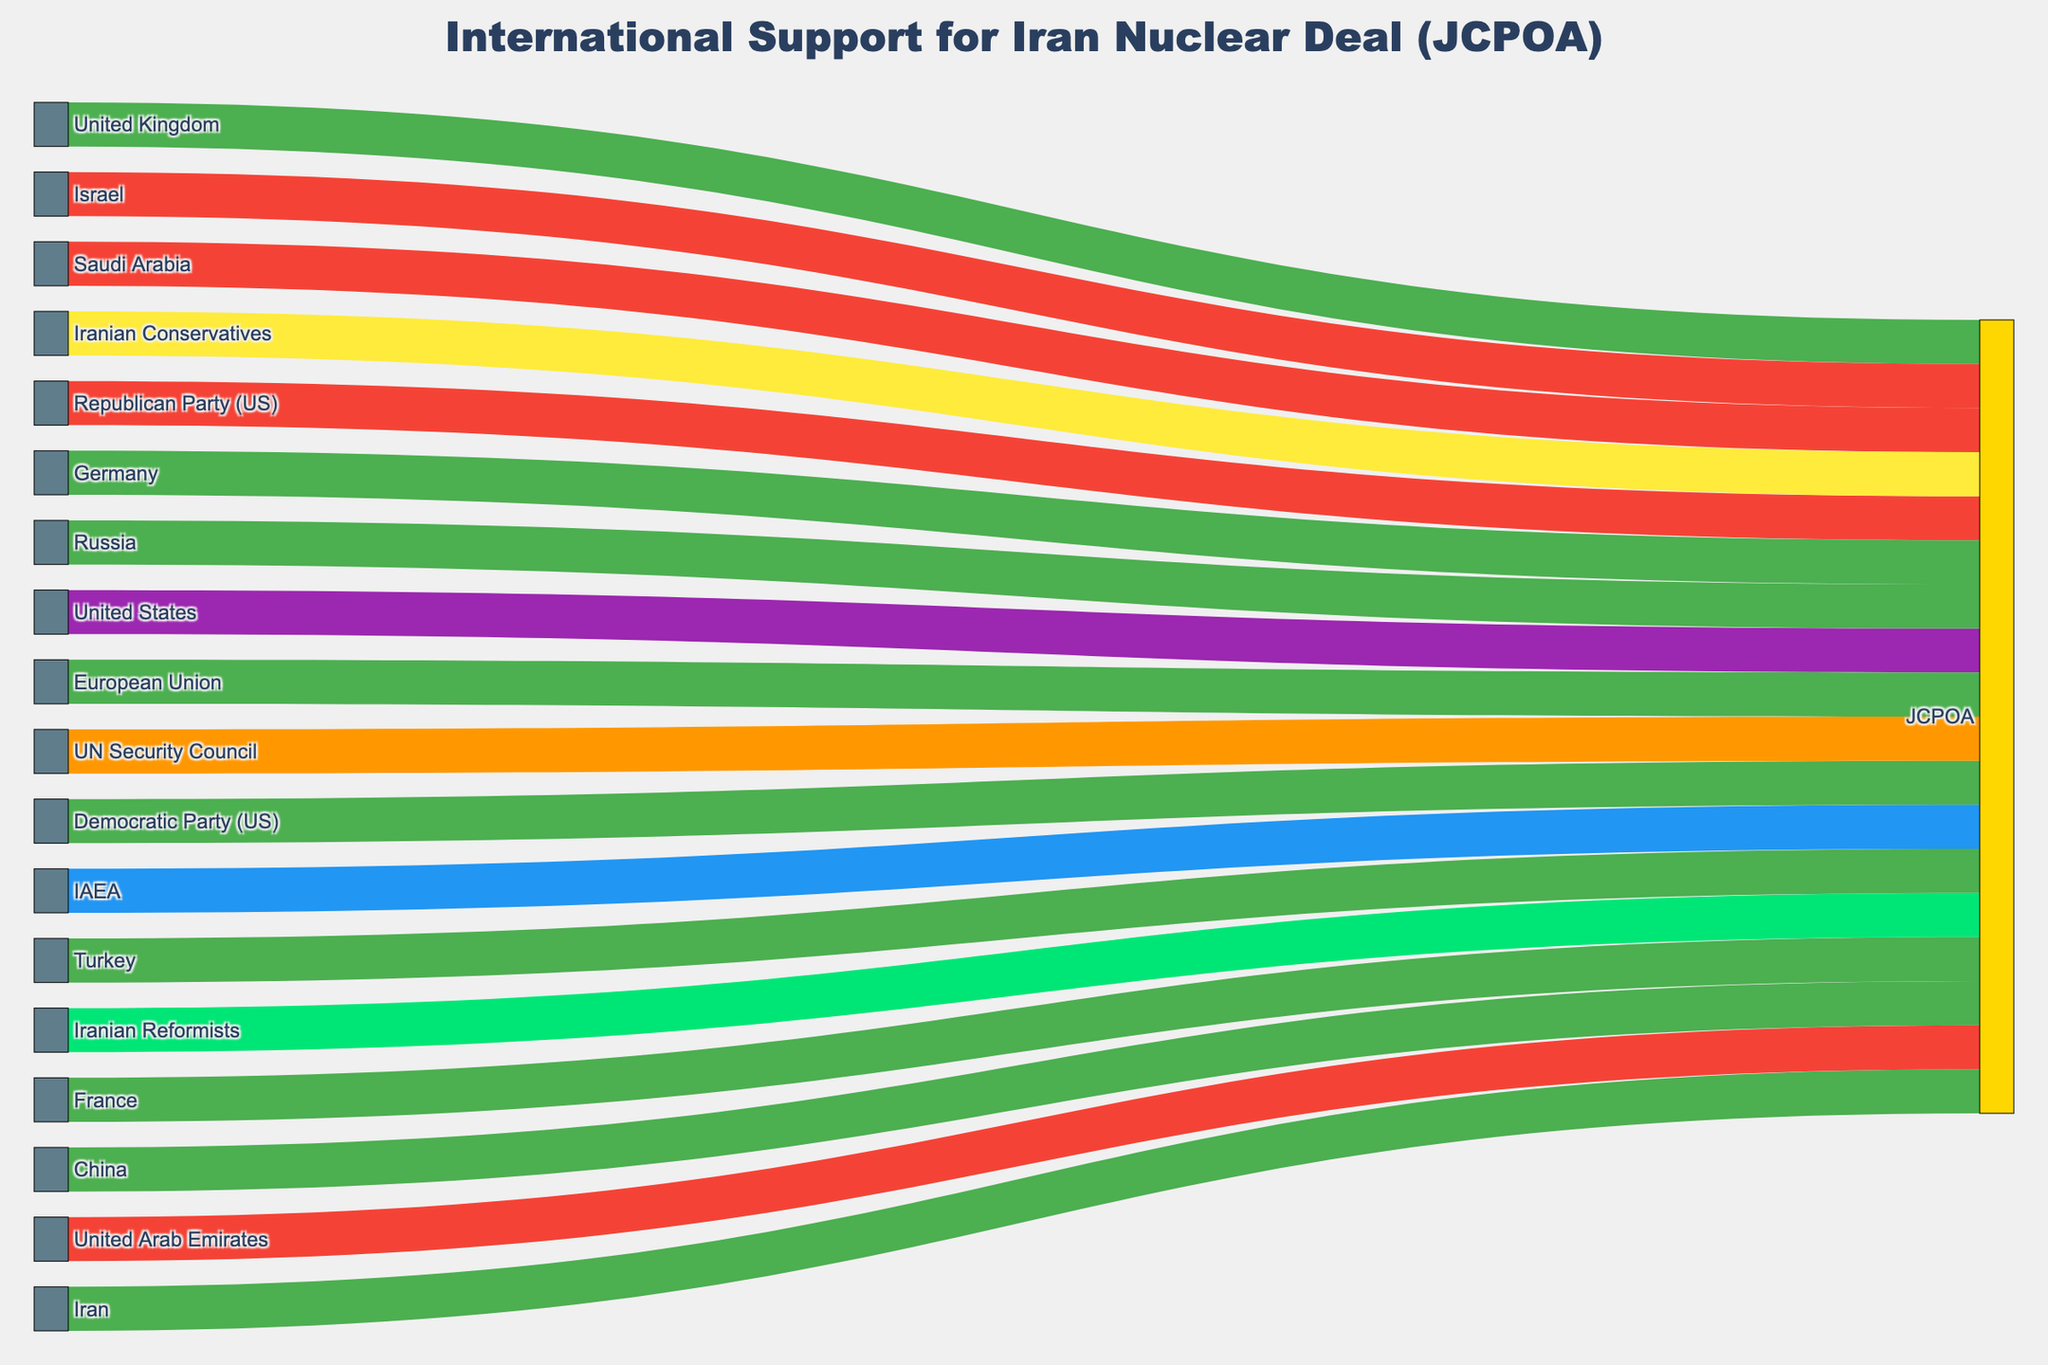What countries support the JCPOA? The diagram shows connections from various countries to the JCPOA labeled "Supports."
Answer: Iran, European Union, Russia, China, United Kingdom, France, Germany, and Turkey Which political party in the United States opposes the JCPOA? The diagram shows a connection from the "Republican Party (US)" labeled "Opposes" to the JCPOA.
Answer: Republican Party (US) How many entities have a "Supports" stance towards the JCPOA? Count the entities with a "Supports" stance connected to the JCPOA: Iran, European Union, Russia, China, United Kingdom, France, Germany, and Turkey.
Answer: 8 Which country has a divided stance on the JCPOA? The diagram shows a connection from the "United States" labeled "Divided" to the JCPOA.
Answer: United States Which international organizations are involved in the JCPOA and what are their roles? The diagram shows connections from international organizations to the JCPOA: "IAEA" labeled "Monitors" and "UN Security Council" labeled "Endorses."
Answer: IAEA (Monitors), UN Security Council (Endorses) Compare the stance of Iranian Reformists and Iranian Conservatives towards the JCPOA. The diagram shows connections from "Iranian Reformists" labeled "Strongly Supports" and "Iranian Conservatives" labeled "Cautiously Accepts" to the JCPOA.
Answer: Iranian Reformists (Strongly Supports), Iranian Conservatives (Cautiously Accepts) Which Middle Eastern countries oppose the JCPOA? The diagram shows connections from Middle Eastern countries labeled "Opposes" to the JCPOA: Israel, Saudi Arabia, and United Arab Emirates.
Answer: Israel, Saudi Arabia, United Arab Emirates Which group has the strongest level of support for the JCPOA? The diagram shows the most supportive stance labeled "Strongly Supports" connected from "Iranian Reformists" to the JCPOA.
Answer: Iranian Reformists What is the total number of entities depicted in the diagram? Count all unique entities listed as sources and targets in the diagram.
Answer: 17 What stance does the Democratic Party in the United States have towards the JCPOA? The diagram shows a connection from the "Democratic Party (US)" labeled "Supports" to the JCPOA.
Answer: Supports 